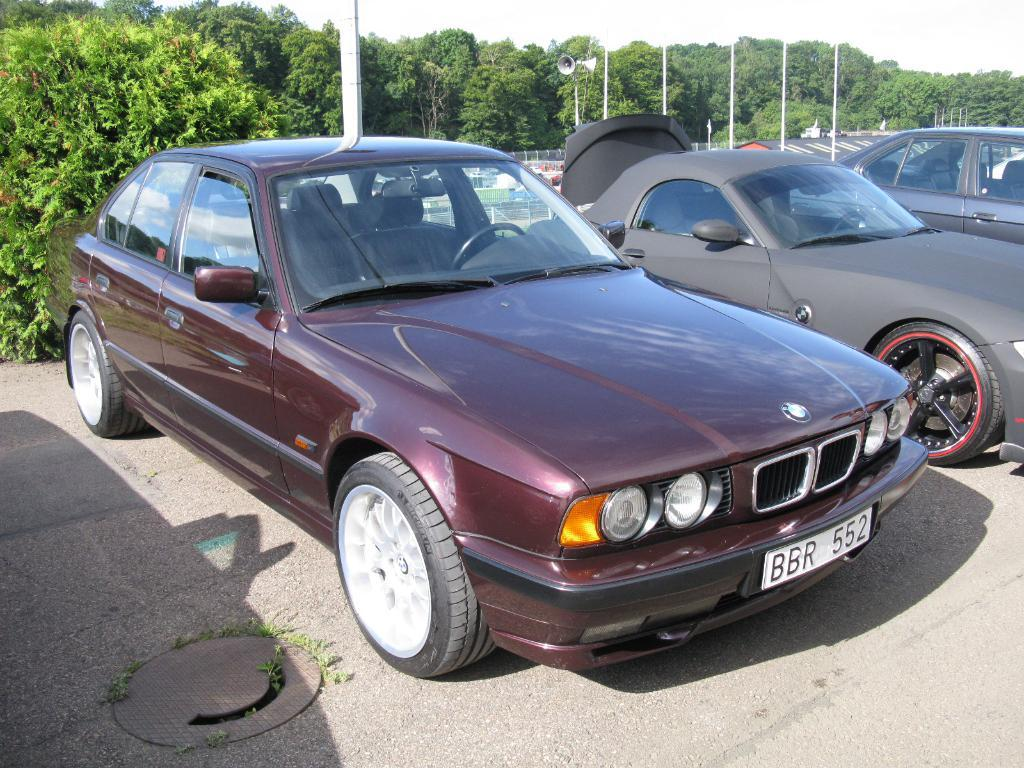How many cars are present in the image? There are three cars in the image. How are the cars arranged in the image? The cars are parked behind each other. What else can be seen in the image besides the cars? There are poles, speakers, trees, and a road visible in the image. How many speakers are attached to the poles? There are two speakers attached to the poles. What type of pets can be seen playing in the hall in the image? There is no hall or pets present in the image. Can you describe the bee buzzing around the cars in the image? There are no bees present in the image; only cars, poles, speakers, trees, and a road are visible. 